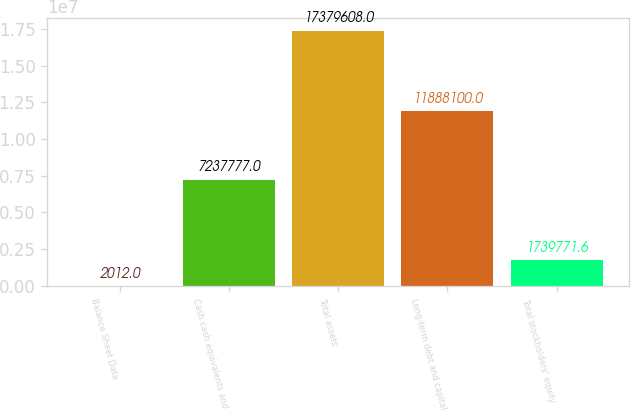<chart> <loc_0><loc_0><loc_500><loc_500><bar_chart><fcel>Balance Sheet Data<fcel>Cash cash equivalents and<fcel>Total assets<fcel>Long-term debt and capital<fcel>Total stockholders' equity<nl><fcel>2012<fcel>7.23778e+06<fcel>1.73796e+07<fcel>1.18881e+07<fcel>1.73977e+06<nl></chart> 